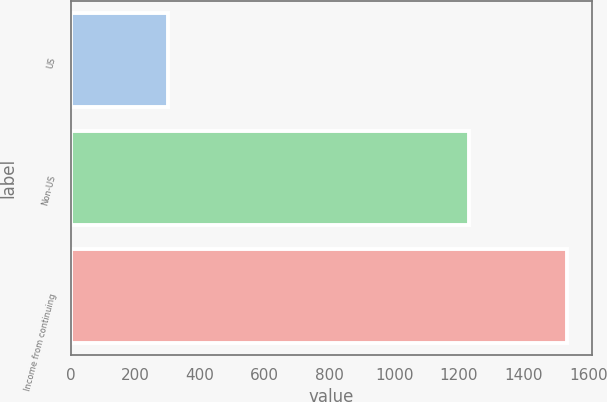Convert chart. <chart><loc_0><loc_0><loc_500><loc_500><bar_chart><fcel>US<fcel>Non-US<fcel>Income from continuing<nl><fcel>302<fcel>1232<fcel>1534<nl></chart> 